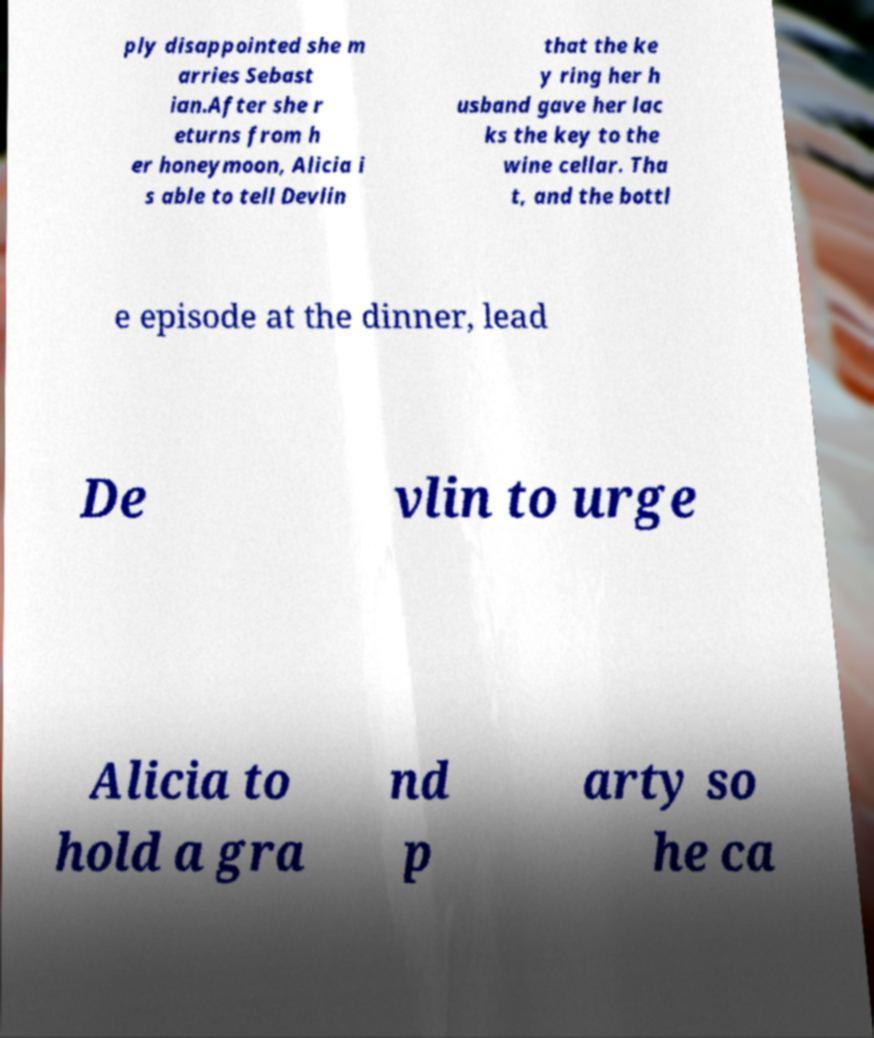Could you assist in decoding the text presented in this image and type it out clearly? ply disappointed she m arries Sebast ian.After she r eturns from h er honeymoon, Alicia i s able to tell Devlin that the ke y ring her h usband gave her lac ks the key to the wine cellar. Tha t, and the bottl e episode at the dinner, lead De vlin to urge Alicia to hold a gra nd p arty so he ca 